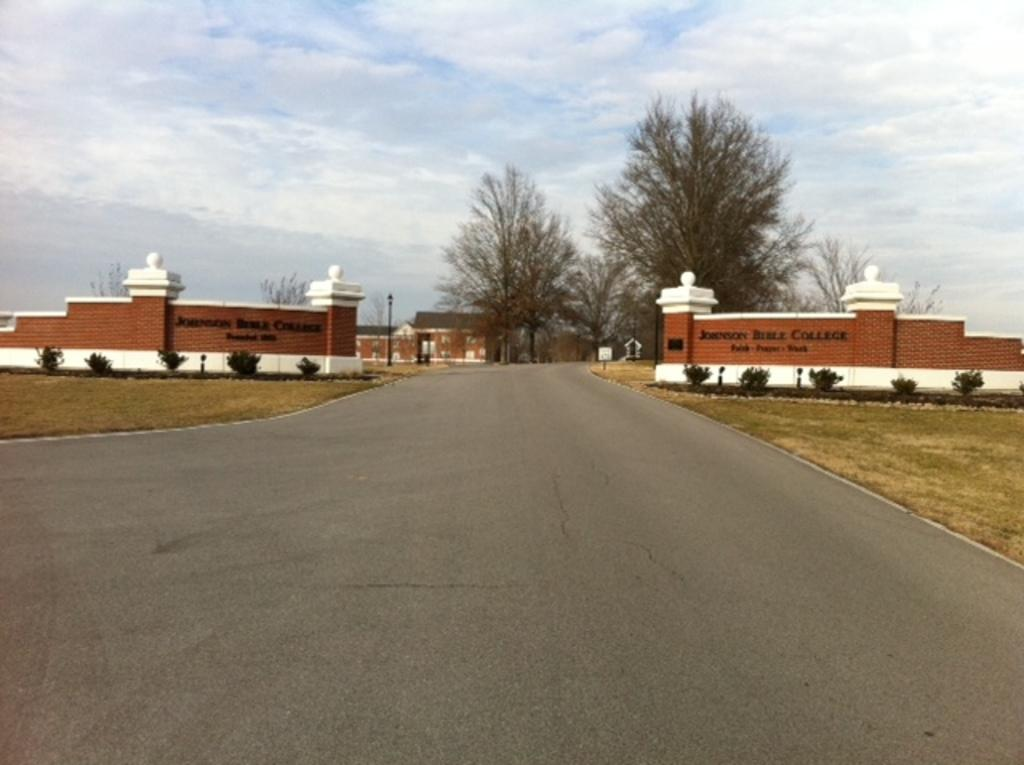What is the main feature of the image? There is a road in the image. What can be seen on either side of the road? There is land on either side of the road. What structures are visible in the background of the image? There is a wall and an entrance in the background of the image. What type of vegetation is present in the background of the image? Trees are present in the background of the image. What part of the natural environment is visible in the image? The sky is visible in the background of the image. How many guitars are hanging on the wall in the image? There are no guitars present in the image; the wall and entrance are the only structures visible in the background. 